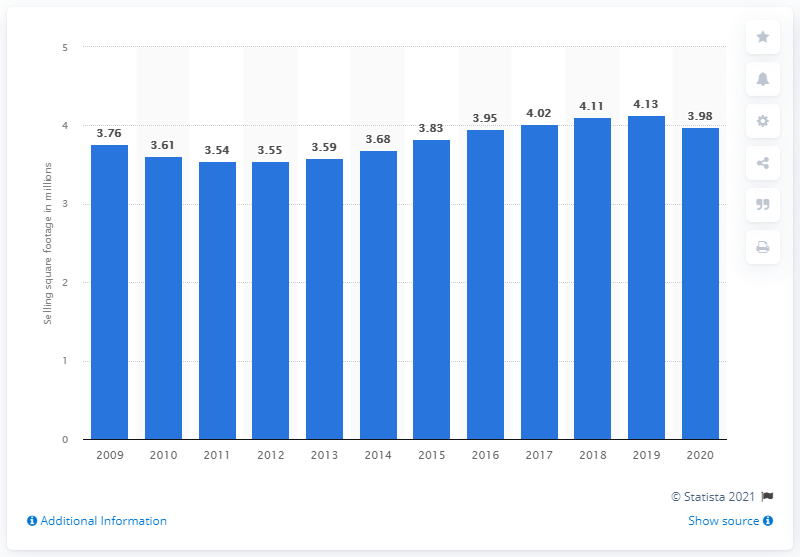Give some essential details in this illustration. Williams-Sonoma's global selling square footage in 2020 was 3.98. A year earlier, Williams-Sonoma's global selling square footage was 4.13... 